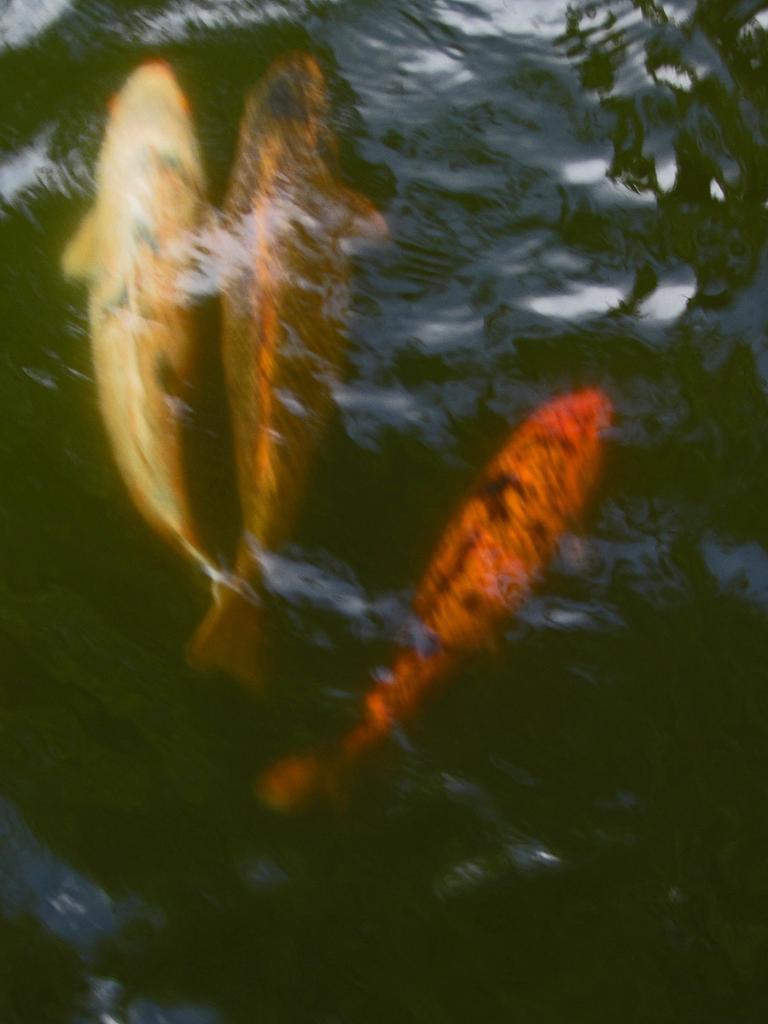How would you summarize this image in a sentence or two? There are three fishes swimming in the water. 